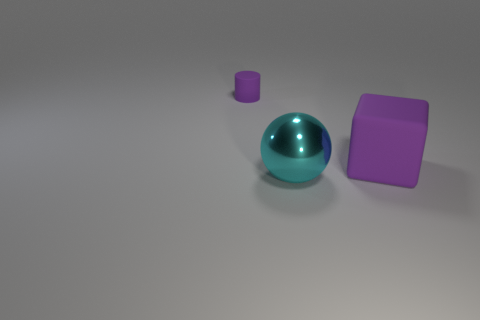Do the purple object that is left of the big metallic sphere and the purple object that is to the right of the tiny rubber thing have the same material?
Offer a very short reply. Yes. The large cyan thing that is in front of the purple rubber thing in front of the cylinder is made of what material?
Give a very brief answer. Metal. What shape is the purple object to the right of the matte cylinder that is left of the purple thing that is right of the tiny object?
Your answer should be compact. Cube. How many large objects are there?
Your answer should be very brief. 2. The purple object in front of the small object has what shape?
Give a very brief answer. Cube. What is the color of the matte object right of the rubber thing that is left of the big cyan thing on the left side of the big purple matte cube?
Keep it short and to the point. Purple. There is a big purple object that is made of the same material as the tiny thing; what is its shape?
Keep it short and to the point. Cube. Is the number of big rubber things less than the number of large yellow shiny cylinders?
Your response must be concise. No. Is the material of the big cyan object the same as the large purple object?
Ensure brevity in your answer.  No. How many other things are the same color as the tiny matte cylinder?
Your answer should be compact. 1. 